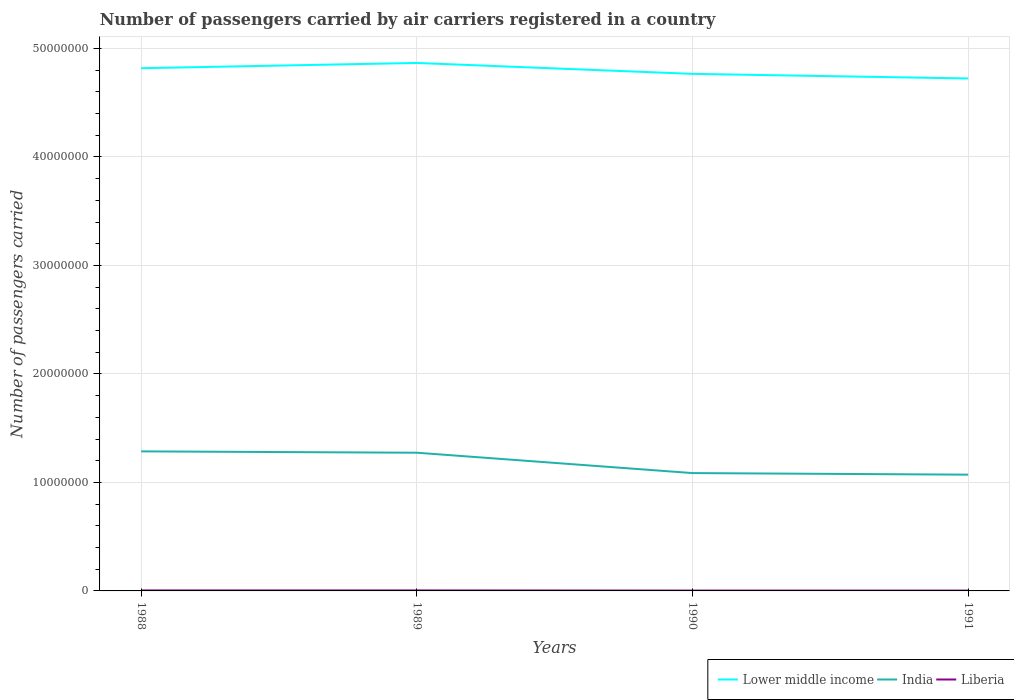Across all years, what is the maximum number of passengers carried by air carriers in Liberia?
Give a very brief answer. 3.20e+04. In which year was the number of passengers carried by air carriers in Lower middle income maximum?
Your response must be concise. 1991. What is the total number of passengers carried by air carriers in India in the graph?
Provide a succinct answer. 2.15e+06. What is the difference between the highest and the second highest number of passengers carried by air carriers in Lower middle income?
Your response must be concise. 1.43e+06. What is the difference between the highest and the lowest number of passengers carried by air carriers in India?
Provide a succinct answer. 2. How many lines are there?
Your response must be concise. 3. How many years are there in the graph?
Make the answer very short. 4. Are the values on the major ticks of Y-axis written in scientific E-notation?
Your response must be concise. No. Does the graph contain any zero values?
Make the answer very short. No. Does the graph contain grids?
Provide a short and direct response. Yes. Where does the legend appear in the graph?
Provide a succinct answer. Bottom right. How are the legend labels stacked?
Offer a terse response. Horizontal. What is the title of the graph?
Make the answer very short. Number of passengers carried by air carriers registered in a country. Does "Ireland" appear as one of the legend labels in the graph?
Offer a very short reply. No. What is the label or title of the X-axis?
Your answer should be very brief. Years. What is the label or title of the Y-axis?
Your answer should be compact. Number of passengers carried. What is the Number of passengers carried in Lower middle income in 1988?
Provide a short and direct response. 4.82e+07. What is the Number of passengers carried in India in 1988?
Your response must be concise. 1.29e+07. What is the Number of passengers carried of Liberia in 1988?
Offer a terse response. 4.57e+04. What is the Number of passengers carried of Lower middle income in 1989?
Make the answer very short. 4.87e+07. What is the Number of passengers carried in India in 1989?
Provide a succinct answer. 1.27e+07. What is the Number of passengers carried in Liberia in 1989?
Offer a terse response. 4.63e+04. What is the Number of passengers carried of Lower middle income in 1990?
Your answer should be very brief. 4.77e+07. What is the Number of passengers carried in India in 1990?
Keep it short and to the point. 1.09e+07. What is the Number of passengers carried in Liberia in 1990?
Your answer should be compact. 3.37e+04. What is the Number of passengers carried of Lower middle income in 1991?
Ensure brevity in your answer.  4.72e+07. What is the Number of passengers carried in India in 1991?
Ensure brevity in your answer.  1.07e+07. What is the Number of passengers carried in Liberia in 1991?
Your response must be concise. 3.20e+04. Across all years, what is the maximum Number of passengers carried in Lower middle income?
Make the answer very short. 4.87e+07. Across all years, what is the maximum Number of passengers carried in India?
Make the answer very short. 1.29e+07. Across all years, what is the maximum Number of passengers carried in Liberia?
Your answer should be very brief. 4.63e+04. Across all years, what is the minimum Number of passengers carried of Lower middle income?
Ensure brevity in your answer.  4.72e+07. Across all years, what is the minimum Number of passengers carried of India?
Your answer should be compact. 1.07e+07. Across all years, what is the minimum Number of passengers carried of Liberia?
Ensure brevity in your answer.  3.20e+04. What is the total Number of passengers carried in Lower middle income in the graph?
Provide a short and direct response. 1.92e+08. What is the total Number of passengers carried in India in the graph?
Give a very brief answer. 4.72e+07. What is the total Number of passengers carried of Liberia in the graph?
Your answer should be compact. 1.58e+05. What is the difference between the Number of passengers carried of Lower middle income in 1988 and that in 1989?
Your answer should be very brief. -4.84e+05. What is the difference between the Number of passengers carried of India in 1988 and that in 1989?
Provide a short and direct response. 1.23e+05. What is the difference between the Number of passengers carried in Liberia in 1988 and that in 1989?
Provide a short and direct response. -600. What is the difference between the Number of passengers carried in Lower middle income in 1988 and that in 1990?
Your answer should be very brief. 5.21e+05. What is the difference between the Number of passengers carried in India in 1988 and that in 1990?
Your response must be concise. 2.00e+06. What is the difference between the Number of passengers carried of Liberia in 1988 and that in 1990?
Provide a short and direct response. 1.20e+04. What is the difference between the Number of passengers carried in Lower middle income in 1988 and that in 1991?
Your answer should be compact. 9.44e+05. What is the difference between the Number of passengers carried of India in 1988 and that in 1991?
Offer a very short reply. 2.15e+06. What is the difference between the Number of passengers carried in Liberia in 1988 and that in 1991?
Offer a very short reply. 1.37e+04. What is the difference between the Number of passengers carried of Lower middle income in 1989 and that in 1990?
Provide a short and direct response. 1.00e+06. What is the difference between the Number of passengers carried in India in 1989 and that in 1990?
Make the answer very short. 1.88e+06. What is the difference between the Number of passengers carried of Liberia in 1989 and that in 1990?
Your response must be concise. 1.26e+04. What is the difference between the Number of passengers carried in Lower middle income in 1989 and that in 1991?
Your answer should be compact. 1.43e+06. What is the difference between the Number of passengers carried of India in 1989 and that in 1991?
Keep it short and to the point. 2.02e+06. What is the difference between the Number of passengers carried in Liberia in 1989 and that in 1991?
Provide a short and direct response. 1.43e+04. What is the difference between the Number of passengers carried of Lower middle income in 1990 and that in 1991?
Ensure brevity in your answer.  4.23e+05. What is the difference between the Number of passengers carried in India in 1990 and that in 1991?
Ensure brevity in your answer.  1.45e+05. What is the difference between the Number of passengers carried in Liberia in 1990 and that in 1991?
Your response must be concise. 1700. What is the difference between the Number of passengers carried of Lower middle income in 1988 and the Number of passengers carried of India in 1989?
Your answer should be compact. 3.54e+07. What is the difference between the Number of passengers carried in Lower middle income in 1988 and the Number of passengers carried in Liberia in 1989?
Provide a succinct answer. 4.81e+07. What is the difference between the Number of passengers carried in India in 1988 and the Number of passengers carried in Liberia in 1989?
Provide a succinct answer. 1.28e+07. What is the difference between the Number of passengers carried of Lower middle income in 1988 and the Number of passengers carried of India in 1990?
Keep it short and to the point. 3.73e+07. What is the difference between the Number of passengers carried of Lower middle income in 1988 and the Number of passengers carried of Liberia in 1990?
Your answer should be compact. 4.82e+07. What is the difference between the Number of passengers carried in India in 1988 and the Number of passengers carried in Liberia in 1990?
Ensure brevity in your answer.  1.28e+07. What is the difference between the Number of passengers carried in Lower middle income in 1988 and the Number of passengers carried in India in 1991?
Offer a very short reply. 3.75e+07. What is the difference between the Number of passengers carried of Lower middle income in 1988 and the Number of passengers carried of Liberia in 1991?
Offer a terse response. 4.82e+07. What is the difference between the Number of passengers carried of India in 1988 and the Number of passengers carried of Liberia in 1991?
Ensure brevity in your answer.  1.28e+07. What is the difference between the Number of passengers carried in Lower middle income in 1989 and the Number of passengers carried in India in 1990?
Keep it short and to the point. 3.78e+07. What is the difference between the Number of passengers carried of Lower middle income in 1989 and the Number of passengers carried of Liberia in 1990?
Provide a short and direct response. 4.86e+07. What is the difference between the Number of passengers carried in India in 1989 and the Number of passengers carried in Liberia in 1990?
Make the answer very short. 1.27e+07. What is the difference between the Number of passengers carried in Lower middle income in 1989 and the Number of passengers carried in India in 1991?
Your answer should be compact. 3.80e+07. What is the difference between the Number of passengers carried in Lower middle income in 1989 and the Number of passengers carried in Liberia in 1991?
Provide a succinct answer. 4.86e+07. What is the difference between the Number of passengers carried in India in 1989 and the Number of passengers carried in Liberia in 1991?
Your answer should be compact. 1.27e+07. What is the difference between the Number of passengers carried in Lower middle income in 1990 and the Number of passengers carried in India in 1991?
Make the answer very short. 3.69e+07. What is the difference between the Number of passengers carried in Lower middle income in 1990 and the Number of passengers carried in Liberia in 1991?
Give a very brief answer. 4.76e+07. What is the difference between the Number of passengers carried in India in 1990 and the Number of passengers carried in Liberia in 1991?
Make the answer very short. 1.08e+07. What is the average Number of passengers carried of Lower middle income per year?
Keep it short and to the point. 4.79e+07. What is the average Number of passengers carried of India per year?
Offer a terse response. 1.18e+07. What is the average Number of passengers carried in Liberia per year?
Keep it short and to the point. 3.94e+04. In the year 1988, what is the difference between the Number of passengers carried of Lower middle income and Number of passengers carried of India?
Keep it short and to the point. 3.53e+07. In the year 1988, what is the difference between the Number of passengers carried of Lower middle income and Number of passengers carried of Liberia?
Provide a succinct answer. 4.81e+07. In the year 1988, what is the difference between the Number of passengers carried in India and Number of passengers carried in Liberia?
Give a very brief answer. 1.28e+07. In the year 1989, what is the difference between the Number of passengers carried in Lower middle income and Number of passengers carried in India?
Offer a terse response. 3.59e+07. In the year 1989, what is the difference between the Number of passengers carried in Lower middle income and Number of passengers carried in Liberia?
Offer a terse response. 4.86e+07. In the year 1989, what is the difference between the Number of passengers carried of India and Number of passengers carried of Liberia?
Make the answer very short. 1.27e+07. In the year 1990, what is the difference between the Number of passengers carried in Lower middle income and Number of passengers carried in India?
Make the answer very short. 3.68e+07. In the year 1990, what is the difference between the Number of passengers carried of Lower middle income and Number of passengers carried of Liberia?
Make the answer very short. 4.76e+07. In the year 1990, what is the difference between the Number of passengers carried in India and Number of passengers carried in Liberia?
Provide a short and direct response. 1.08e+07. In the year 1991, what is the difference between the Number of passengers carried of Lower middle income and Number of passengers carried of India?
Give a very brief answer. 3.65e+07. In the year 1991, what is the difference between the Number of passengers carried in Lower middle income and Number of passengers carried in Liberia?
Provide a short and direct response. 4.72e+07. In the year 1991, what is the difference between the Number of passengers carried in India and Number of passengers carried in Liberia?
Ensure brevity in your answer.  1.07e+07. What is the ratio of the Number of passengers carried in India in 1988 to that in 1989?
Give a very brief answer. 1.01. What is the ratio of the Number of passengers carried in Liberia in 1988 to that in 1989?
Make the answer very short. 0.99. What is the ratio of the Number of passengers carried in Lower middle income in 1988 to that in 1990?
Provide a short and direct response. 1.01. What is the ratio of the Number of passengers carried in India in 1988 to that in 1990?
Offer a terse response. 1.18. What is the ratio of the Number of passengers carried of Liberia in 1988 to that in 1990?
Give a very brief answer. 1.36. What is the ratio of the Number of passengers carried in India in 1988 to that in 1991?
Ensure brevity in your answer.  1.2. What is the ratio of the Number of passengers carried of Liberia in 1988 to that in 1991?
Provide a succinct answer. 1.43. What is the ratio of the Number of passengers carried in Lower middle income in 1989 to that in 1990?
Your response must be concise. 1.02. What is the ratio of the Number of passengers carried of India in 1989 to that in 1990?
Provide a short and direct response. 1.17. What is the ratio of the Number of passengers carried of Liberia in 1989 to that in 1990?
Keep it short and to the point. 1.37. What is the ratio of the Number of passengers carried of Lower middle income in 1989 to that in 1991?
Your answer should be compact. 1.03. What is the ratio of the Number of passengers carried of India in 1989 to that in 1991?
Offer a terse response. 1.19. What is the ratio of the Number of passengers carried of Liberia in 1989 to that in 1991?
Your answer should be very brief. 1.45. What is the ratio of the Number of passengers carried of Lower middle income in 1990 to that in 1991?
Offer a very short reply. 1.01. What is the ratio of the Number of passengers carried of India in 1990 to that in 1991?
Provide a succinct answer. 1.01. What is the ratio of the Number of passengers carried in Liberia in 1990 to that in 1991?
Your answer should be very brief. 1.05. What is the difference between the highest and the second highest Number of passengers carried in Lower middle income?
Ensure brevity in your answer.  4.84e+05. What is the difference between the highest and the second highest Number of passengers carried of India?
Provide a succinct answer. 1.23e+05. What is the difference between the highest and the second highest Number of passengers carried in Liberia?
Your response must be concise. 600. What is the difference between the highest and the lowest Number of passengers carried of Lower middle income?
Your answer should be very brief. 1.43e+06. What is the difference between the highest and the lowest Number of passengers carried in India?
Your answer should be very brief. 2.15e+06. What is the difference between the highest and the lowest Number of passengers carried in Liberia?
Give a very brief answer. 1.43e+04. 